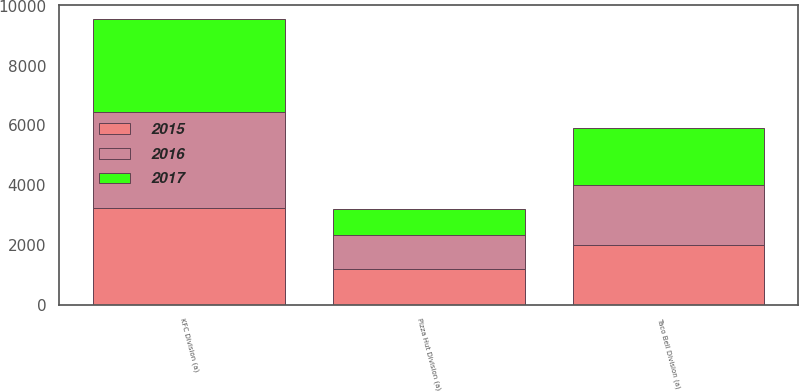Convert chart. <chart><loc_0><loc_0><loc_500><loc_500><stacked_bar_chart><ecel><fcel>KFC Division (a)<fcel>Pizza Hut Division (a)<fcel>Taco Bell Division (a)<nl><fcel>2017<fcel>3110<fcel>893<fcel>1880<nl><fcel>2016<fcel>3225<fcel>1108<fcel>2025<nl><fcel>2015<fcel>3222<fcel>1205<fcel>1991<nl></chart> 